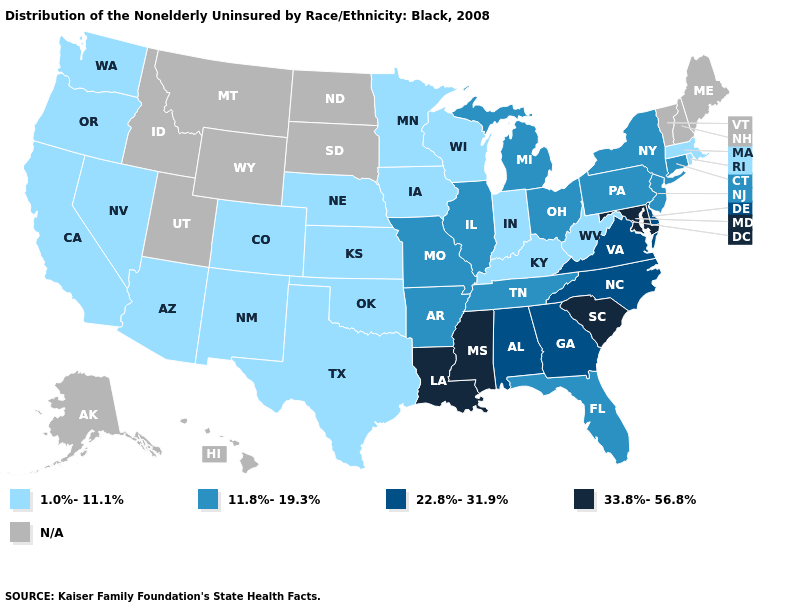What is the highest value in the USA?
Answer briefly. 33.8%-56.8%. Name the states that have a value in the range 33.8%-56.8%?
Give a very brief answer. Louisiana, Maryland, Mississippi, South Carolina. What is the value of Arkansas?
Quick response, please. 11.8%-19.3%. What is the highest value in the West ?
Be succinct. 1.0%-11.1%. Name the states that have a value in the range 11.8%-19.3%?
Keep it brief. Arkansas, Connecticut, Florida, Illinois, Michigan, Missouri, New Jersey, New York, Ohio, Pennsylvania, Tennessee. Name the states that have a value in the range N/A?
Keep it brief. Alaska, Hawaii, Idaho, Maine, Montana, New Hampshire, North Dakota, South Dakota, Utah, Vermont, Wyoming. What is the lowest value in states that border Arkansas?
Answer briefly. 1.0%-11.1%. Does South Carolina have the highest value in the USA?
Answer briefly. Yes. Name the states that have a value in the range N/A?
Short answer required. Alaska, Hawaii, Idaho, Maine, Montana, New Hampshire, North Dakota, South Dakota, Utah, Vermont, Wyoming. What is the value of Kansas?
Concise answer only. 1.0%-11.1%. Among the states that border Nebraska , which have the highest value?
Be succinct. Missouri. Among the states that border Louisiana , which have the highest value?
Answer briefly. Mississippi. What is the highest value in states that border Arkansas?
Short answer required. 33.8%-56.8%. 